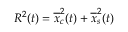<formula> <loc_0><loc_0><loc_500><loc_500>R ^ { 2 } ( t ) = \overline { x } _ { c } ^ { 2 } ( t ) + \overline { x } _ { s } ^ { 2 } ( t )</formula> 